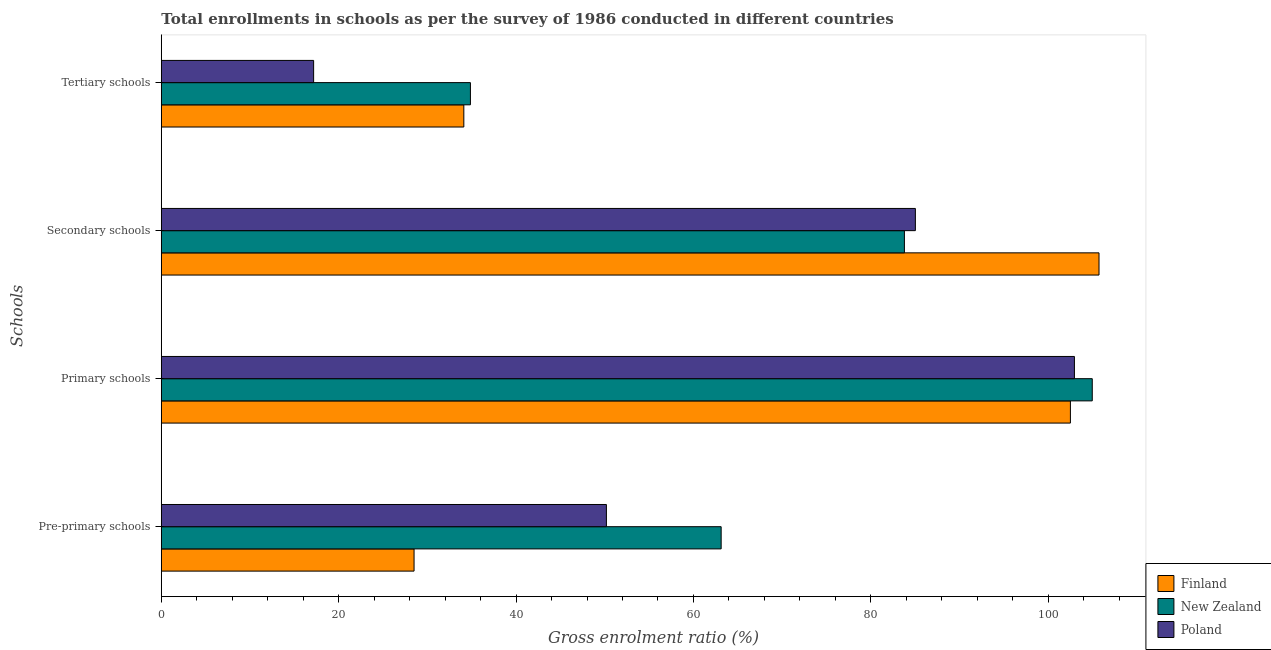Are the number of bars on each tick of the Y-axis equal?
Ensure brevity in your answer.  Yes. How many bars are there on the 1st tick from the top?
Your answer should be compact. 3. What is the label of the 2nd group of bars from the top?
Provide a succinct answer. Secondary schools. What is the gross enrolment ratio in pre-primary schools in New Zealand?
Offer a very short reply. 63.12. Across all countries, what is the maximum gross enrolment ratio in tertiary schools?
Your response must be concise. 34.85. Across all countries, what is the minimum gross enrolment ratio in pre-primary schools?
Offer a terse response. 28.5. In which country was the gross enrolment ratio in pre-primary schools maximum?
Your answer should be very brief. New Zealand. What is the total gross enrolment ratio in primary schools in the graph?
Offer a very short reply. 310.42. What is the difference between the gross enrolment ratio in secondary schools in Finland and that in New Zealand?
Offer a very short reply. 21.94. What is the difference between the gross enrolment ratio in tertiary schools in New Zealand and the gross enrolment ratio in primary schools in Finland?
Ensure brevity in your answer.  -67.65. What is the average gross enrolment ratio in pre-primary schools per country?
Ensure brevity in your answer.  47.27. What is the difference between the gross enrolment ratio in secondary schools and gross enrolment ratio in tertiary schools in Poland?
Your answer should be very brief. 67.85. In how many countries, is the gross enrolment ratio in primary schools greater than 52 %?
Make the answer very short. 3. What is the ratio of the gross enrolment ratio in primary schools in Finland to that in Poland?
Give a very brief answer. 1. What is the difference between the highest and the second highest gross enrolment ratio in primary schools?
Provide a succinct answer. 2.01. What is the difference between the highest and the lowest gross enrolment ratio in tertiary schools?
Your answer should be very brief. 17.68. Is the sum of the gross enrolment ratio in primary schools in Poland and New Zealand greater than the maximum gross enrolment ratio in tertiary schools across all countries?
Your answer should be compact. Yes. What does the 1st bar from the bottom in Pre-primary schools represents?
Keep it short and to the point. Finland. Is it the case that in every country, the sum of the gross enrolment ratio in pre-primary schools and gross enrolment ratio in primary schools is greater than the gross enrolment ratio in secondary schools?
Make the answer very short. Yes. What is the difference between two consecutive major ticks on the X-axis?
Make the answer very short. 20. Are the values on the major ticks of X-axis written in scientific E-notation?
Provide a succinct answer. No. Does the graph contain grids?
Give a very brief answer. No. How many legend labels are there?
Keep it short and to the point. 3. How are the legend labels stacked?
Provide a succinct answer. Vertical. What is the title of the graph?
Offer a terse response. Total enrollments in schools as per the survey of 1986 conducted in different countries. What is the label or title of the X-axis?
Your answer should be compact. Gross enrolment ratio (%). What is the label or title of the Y-axis?
Provide a short and direct response. Schools. What is the Gross enrolment ratio (%) in Finland in Pre-primary schools?
Your response must be concise. 28.5. What is the Gross enrolment ratio (%) of New Zealand in Pre-primary schools?
Provide a short and direct response. 63.12. What is the Gross enrolment ratio (%) in Poland in Pre-primary schools?
Your answer should be very brief. 50.19. What is the Gross enrolment ratio (%) in Finland in Primary schools?
Offer a very short reply. 102.5. What is the Gross enrolment ratio (%) in New Zealand in Primary schools?
Make the answer very short. 104.97. What is the Gross enrolment ratio (%) of Poland in Primary schools?
Ensure brevity in your answer.  102.95. What is the Gross enrolment ratio (%) in Finland in Secondary schools?
Your answer should be compact. 105.73. What is the Gross enrolment ratio (%) of New Zealand in Secondary schools?
Keep it short and to the point. 83.79. What is the Gross enrolment ratio (%) in Poland in Secondary schools?
Your answer should be very brief. 85.02. What is the Gross enrolment ratio (%) of Finland in Tertiary schools?
Keep it short and to the point. 34.11. What is the Gross enrolment ratio (%) in New Zealand in Tertiary schools?
Your answer should be compact. 34.85. What is the Gross enrolment ratio (%) of Poland in Tertiary schools?
Keep it short and to the point. 17.17. Across all Schools, what is the maximum Gross enrolment ratio (%) in Finland?
Keep it short and to the point. 105.73. Across all Schools, what is the maximum Gross enrolment ratio (%) in New Zealand?
Provide a short and direct response. 104.97. Across all Schools, what is the maximum Gross enrolment ratio (%) of Poland?
Your answer should be very brief. 102.95. Across all Schools, what is the minimum Gross enrolment ratio (%) of Finland?
Ensure brevity in your answer.  28.5. Across all Schools, what is the minimum Gross enrolment ratio (%) of New Zealand?
Ensure brevity in your answer.  34.85. Across all Schools, what is the minimum Gross enrolment ratio (%) in Poland?
Make the answer very short. 17.17. What is the total Gross enrolment ratio (%) in Finland in the graph?
Provide a short and direct response. 270.84. What is the total Gross enrolment ratio (%) in New Zealand in the graph?
Offer a very short reply. 286.73. What is the total Gross enrolment ratio (%) of Poland in the graph?
Make the answer very short. 255.33. What is the difference between the Gross enrolment ratio (%) of Finland in Pre-primary schools and that in Primary schools?
Your response must be concise. -74. What is the difference between the Gross enrolment ratio (%) of New Zealand in Pre-primary schools and that in Primary schools?
Your answer should be very brief. -41.84. What is the difference between the Gross enrolment ratio (%) in Poland in Pre-primary schools and that in Primary schools?
Provide a short and direct response. -52.77. What is the difference between the Gross enrolment ratio (%) of Finland in Pre-primary schools and that in Secondary schools?
Give a very brief answer. -77.23. What is the difference between the Gross enrolment ratio (%) of New Zealand in Pre-primary schools and that in Secondary schools?
Keep it short and to the point. -20.66. What is the difference between the Gross enrolment ratio (%) in Poland in Pre-primary schools and that in Secondary schools?
Provide a succinct answer. -34.84. What is the difference between the Gross enrolment ratio (%) of Finland in Pre-primary schools and that in Tertiary schools?
Provide a short and direct response. -5.61. What is the difference between the Gross enrolment ratio (%) in New Zealand in Pre-primary schools and that in Tertiary schools?
Your response must be concise. 28.27. What is the difference between the Gross enrolment ratio (%) of Poland in Pre-primary schools and that in Tertiary schools?
Ensure brevity in your answer.  33.01. What is the difference between the Gross enrolment ratio (%) in Finland in Primary schools and that in Secondary schools?
Your answer should be compact. -3.23. What is the difference between the Gross enrolment ratio (%) of New Zealand in Primary schools and that in Secondary schools?
Your answer should be compact. 21.18. What is the difference between the Gross enrolment ratio (%) of Poland in Primary schools and that in Secondary schools?
Your answer should be very brief. 17.93. What is the difference between the Gross enrolment ratio (%) of Finland in Primary schools and that in Tertiary schools?
Make the answer very short. 68.39. What is the difference between the Gross enrolment ratio (%) of New Zealand in Primary schools and that in Tertiary schools?
Your answer should be very brief. 70.11. What is the difference between the Gross enrolment ratio (%) of Poland in Primary schools and that in Tertiary schools?
Offer a terse response. 85.78. What is the difference between the Gross enrolment ratio (%) in Finland in Secondary schools and that in Tertiary schools?
Provide a succinct answer. 71.62. What is the difference between the Gross enrolment ratio (%) of New Zealand in Secondary schools and that in Tertiary schools?
Your response must be concise. 48.93. What is the difference between the Gross enrolment ratio (%) in Poland in Secondary schools and that in Tertiary schools?
Your answer should be very brief. 67.85. What is the difference between the Gross enrolment ratio (%) of Finland in Pre-primary schools and the Gross enrolment ratio (%) of New Zealand in Primary schools?
Keep it short and to the point. -76.47. What is the difference between the Gross enrolment ratio (%) in Finland in Pre-primary schools and the Gross enrolment ratio (%) in Poland in Primary schools?
Your response must be concise. -74.46. What is the difference between the Gross enrolment ratio (%) of New Zealand in Pre-primary schools and the Gross enrolment ratio (%) of Poland in Primary schools?
Make the answer very short. -39.83. What is the difference between the Gross enrolment ratio (%) of Finland in Pre-primary schools and the Gross enrolment ratio (%) of New Zealand in Secondary schools?
Keep it short and to the point. -55.29. What is the difference between the Gross enrolment ratio (%) of Finland in Pre-primary schools and the Gross enrolment ratio (%) of Poland in Secondary schools?
Provide a short and direct response. -56.52. What is the difference between the Gross enrolment ratio (%) of New Zealand in Pre-primary schools and the Gross enrolment ratio (%) of Poland in Secondary schools?
Your answer should be compact. -21.9. What is the difference between the Gross enrolment ratio (%) of Finland in Pre-primary schools and the Gross enrolment ratio (%) of New Zealand in Tertiary schools?
Give a very brief answer. -6.35. What is the difference between the Gross enrolment ratio (%) in Finland in Pre-primary schools and the Gross enrolment ratio (%) in Poland in Tertiary schools?
Offer a very short reply. 11.32. What is the difference between the Gross enrolment ratio (%) of New Zealand in Pre-primary schools and the Gross enrolment ratio (%) of Poland in Tertiary schools?
Provide a short and direct response. 45.95. What is the difference between the Gross enrolment ratio (%) of Finland in Primary schools and the Gross enrolment ratio (%) of New Zealand in Secondary schools?
Provide a succinct answer. 18.72. What is the difference between the Gross enrolment ratio (%) in Finland in Primary schools and the Gross enrolment ratio (%) in Poland in Secondary schools?
Make the answer very short. 17.48. What is the difference between the Gross enrolment ratio (%) in New Zealand in Primary schools and the Gross enrolment ratio (%) in Poland in Secondary schools?
Keep it short and to the point. 19.95. What is the difference between the Gross enrolment ratio (%) in Finland in Primary schools and the Gross enrolment ratio (%) in New Zealand in Tertiary schools?
Your answer should be very brief. 67.65. What is the difference between the Gross enrolment ratio (%) in Finland in Primary schools and the Gross enrolment ratio (%) in Poland in Tertiary schools?
Offer a terse response. 85.33. What is the difference between the Gross enrolment ratio (%) of New Zealand in Primary schools and the Gross enrolment ratio (%) of Poland in Tertiary schools?
Your answer should be compact. 87.79. What is the difference between the Gross enrolment ratio (%) in Finland in Secondary schools and the Gross enrolment ratio (%) in New Zealand in Tertiary schools?
Ensure brevity in your answer.  70.88. What is the difference between the Gross enrolment ratio (%) of Finland in Secondary schools and the Gross enrolment ratio (%) of Poland in Tertiary schools?
Your response must be concise. 88.56. What is the difference between the Gross enrolment ratio (%) of New Zealand in Secondary schools and the Gross enrolment ratio (%) of Poland in Tertiary schools?
Offer a very short reply. 66.61. What is the average Gross enrolment ratio (%) of Finland per Schools?
Your answer should be very brief. 67.71. What is the average Gross enrolment ratio (%) in New Zealand per Schools?
Offer a very short reply. 71.68. What is the average Gross enrolment ratio (%) of Poland per Schools?
Provide a short and direct response. 63.83. What is the difference between the Gross enrolment ratio (%) in Finland and Gross enrolment ratio (%) in New Zealand in Pre-primary schools?
Give a very brief answer. -34.63. What is the difference between the Gross enrolment ratio (%) in Finland and Gross enrolment ratio (%) in Poland in Pre-primary schools?
Keep it short and to the point. -21.69. What is the difference between the Gross enrolment ratio (%) in New Zealand and Gross enrolment ratio (%) in Poland in Pre-primary schools?
Offer a very short reply. 12.94. What is the difference between the Gross enrolment ratio (%) in Finland and Gross enrolment ratio (%) in New Zealand in Primary schools?
Give a very brief answer. -2.47. What is the difference between the Gross enrolment ratio (%) in Finland and Gross enrolment ratio (%) in Poland in Primary schools?
Offer a terse response. -0.45. What is the difference between the Gross enrolment ratio (%) of New Zealand and Gross enrolment ratio (%) of Poland in Primary schools?
Your answer should be very brief. 2.01. What is the difference between the Gross enrolment ratio (%) in Finland and Gross enrolment ratio (%) in New Zealand in Secondary schools?
Your answer should be very brief. 21.94. What is the difference between the Gross enrolment ratio (%) of Finland and Gross enrolment ratio (%) of Poland in Secondary schools?
Your response must be concise. 20.71. What is the difference between the Gross enrolment ratio (%) of New Zealand and Gross enrolment ratio (%) of Poland in Secondary schools?
Provide a succinct answer. -1.24. What is the difference between the Gross enrolment ratio (%) in Finland and Gross enrolment ratio (%) in New Zealand in Tertiary schools?
Keep it short and to the point. -0.74. What is the difference between the Gross enrolment ratio (%) of Finland and Gross enrolment ratio (%) of Poland in Tertiary schools?
Your answer should be very brief. 16.94. What is the difference between the Gross enrolment ratio (%) of New Zealand and Gross enrolment ratio (%) of Poland in Tertiary schools?
Your response must be concise. 17.68. What is the ratio of the Gross enrolment ratio (%) in Finland in Pre-primary schools to that in Primary schools?
Your answer should be very brief. 0.28. What is the ratio of the Gross enrolment ratio (%) of New Zealand in Pre-primary schools to that in Primary schools?
Offer a very short reply. 0.6. What is the ratio of the Gross enrolment ratio (%) of Poland in Pre-primary schools to that in Primary schools?
Your answer should be very brief. 0.49. What is the ratio of the Gross enrolment ratio (%) of Finland in Pre-primary schools to that in Secondary schools?
Offer a terse response. 0.27. What is the ratio of the Gross enrolment ratio (%) in New Zealand in Pre-primary schools to that in Secondary schools?
Offer a terse response. 0.75. What is the ratio of the Gross enrolment ratio (%) in Poland in Pre-primary schools to that in Secondary schools?
Make the answer very short. 0.59. What is the ratio of the Gross enrolment ratio (%) in Finland in Pre-primary schools to that in Tertiary schools?
Ensure brevity in your answer.  0.84. What is the ratio of the Gross enrolment ratio (%) in New Zealand in Pre-primary schools to that in Tertiary schools?
Provide a short and direct response. 1.81. What is the ratio of the Gross enrolment ratio (%) of Poland in Pre-primary schools to that in Tertiary schools?
Your response must be concise. 2.92. What is the ratio of the Gross enrolment ratio (%) of Finland in Primary schools to that in Secondary schools?
Make the answer very short. 0.97. What is the ratio of the Gross enrolment ratio (%) in New Zealand in Primary schools to that in Secondary schools?
Your response must be concise. 1.25. What is the ratio of the Gross enrolment ratio (%) of Poland in Primary schools to that in Secondary schools?
Provide a succinct answer. 1.21. What is the ratio of the Gross enrolment ratio (%) in Finland in Primary schools to that in Tertiary schools?
Provide a short and direct response. 3.01. What is the ratio of the Gross enrolment ratio (%) of New Zealand in Primary schools to that in Tertiary schools?
Keep it short and to the point. 3.01. What is the ratio of the Gross enrolment ratio (%) in Poland in Primary schools to that in Tertiary schools?
Give a very brief answer. 6. What is the ratio of the Gross enrolment ratio (%) of Finland in Secondary schools to that in Tertiary schools?
Offer a very short reply. 3.1. What is the ratio of the Gross enrolment ratio (%) of New Zealand in Secondary schools to that in Tertiary schools?
Make the answer very short. 2.4. What is the ratio of the Gross enrolment ratio (%) in Poland in Secondary schools to that in Tertiary schools?
Your answer should be compact. 4.95. What is the difference between the highest and the second highest Gross enrolment ratio (%) of Finland?
Make the answer very short. 3.23. What is the difference between the highest and the second highest Gross enrolment ratio (%) of New Zealand?
Offer a very short reply. 21.18. What is the difference between the highest and the second highest Gross enrolment ratio (%) of Poland?
Offer a terse response. 17.93. What is the difference between the highest and the lowest Gross enrolment ratio (%) of Finland?
Ensure brevity in your answer.  77.23. What is the difference between the highest and the lowest Gross enrolment ratio (%) of New Zealand?
Provide a succinct answer. 70.11. What is the difference between the highest and the lowest Gross enrolment ratio (%) of Poland?
Keep it short and to the point. 85.78. 